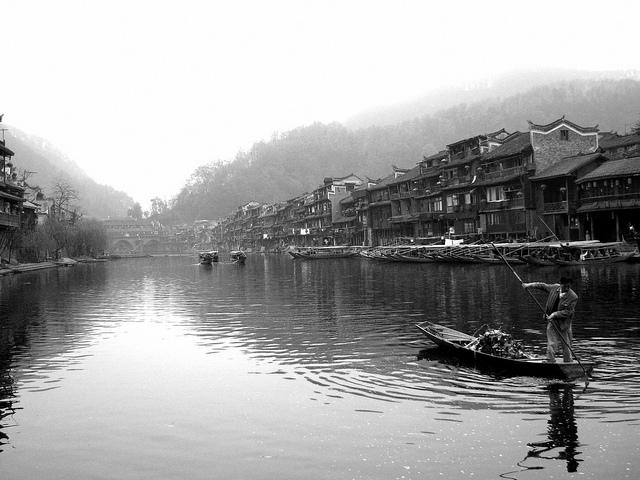Which type action propels the nearest boat forward?

Choices:
A) poking
B) motor
C) none
D) rowing poking 